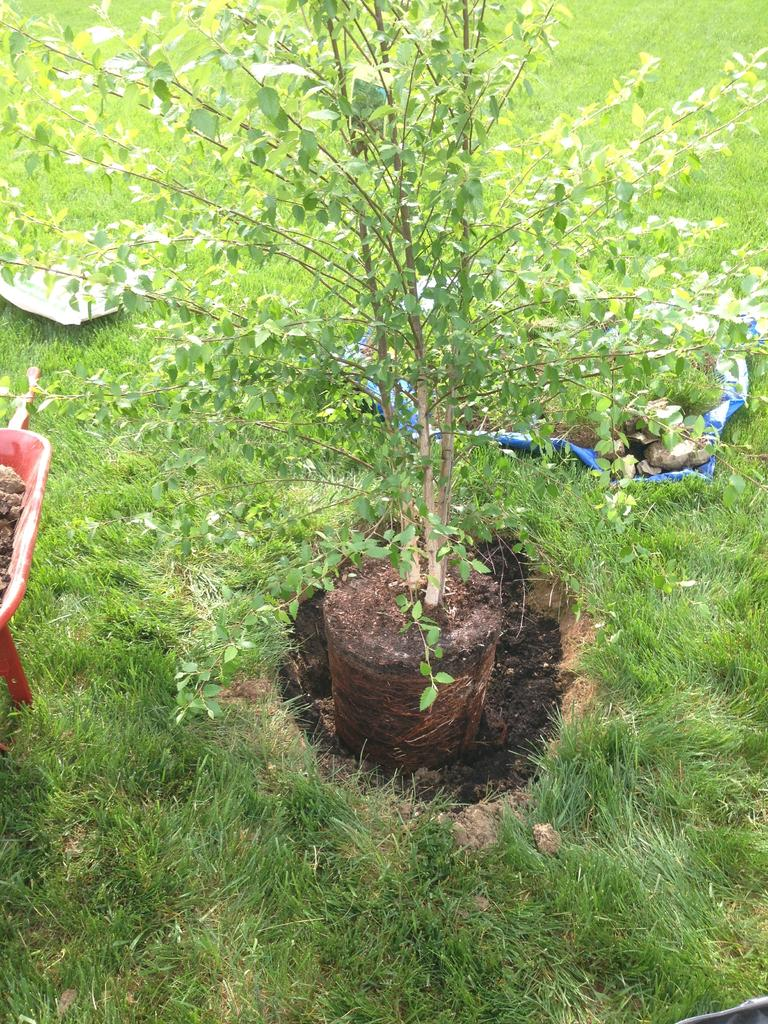What is the main subject in the center of the image? There is a plant in the center of the image. What type of vegetation is at the bottom of the image? There is grass at the bottom of the image. What can be seen on the left side of the image? There is an object on the left side of the image. What is the texture or consistency of the ground in the image? There is mud in the image. What is visible in the background of the image? There are objects visible in the background of the image. What type of whistle is the lawyer using in the image? There is no lawyer or whistle present in the image. Can you describe the flight of the bird in the image? There is no bird or flight in the image; it features a plant, grass, an object, mud, and objects in the background. 